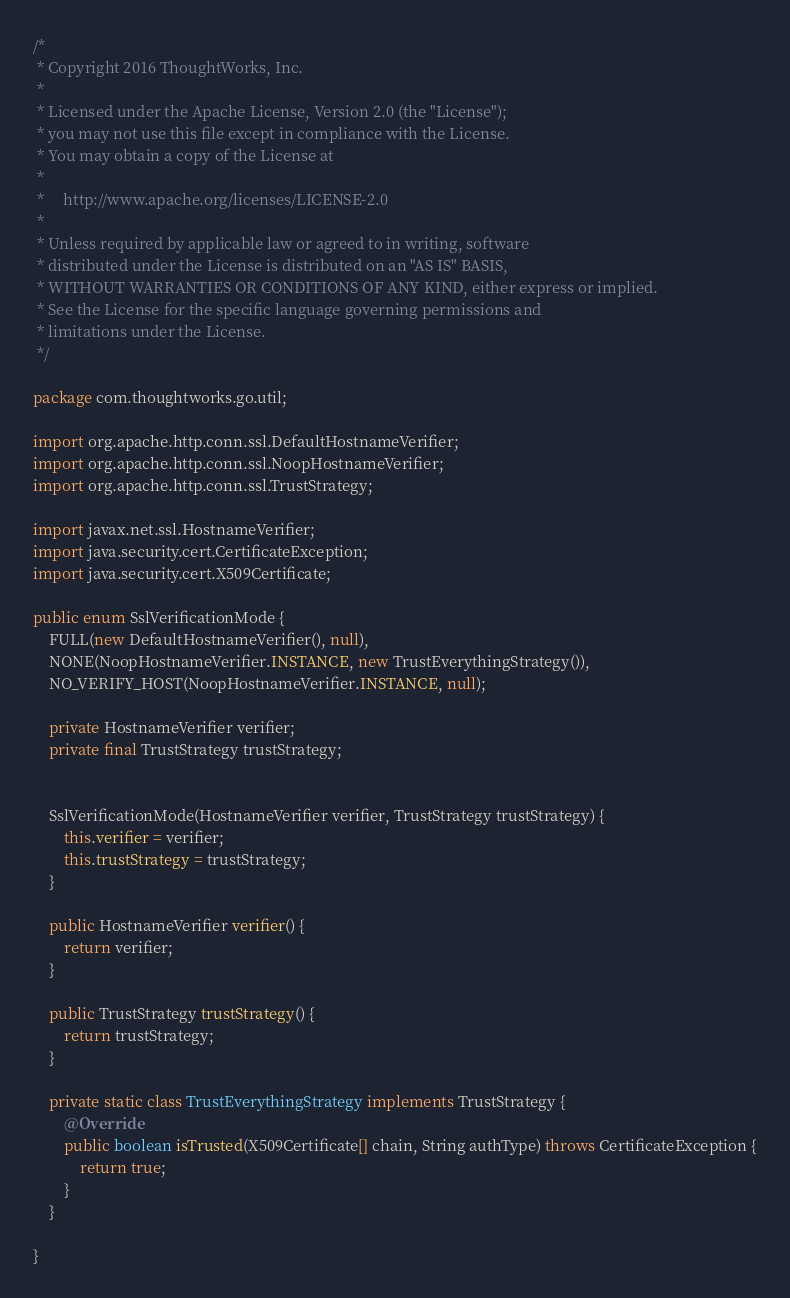Convert code to text. <code><loc_0><loc_0><loc_500><loc_500><_Java_>/*
 * Copyright 2016 ThoughtWorks, Inc.
 *
 * Licensed under the Apache License, Version 2.0 (the "License");
 * you may not use this file except in compliance with the License.
 * You may obtain a copy of the License at
 *
 *     http://www.apache.org/licenses/LICENSE-2.0
 *
 * Unless required by applicable law or agreed to in writing, software
 * distributed under the License is distributed on an "AS IS" BASIS,
 * WITHOUT WARRANTIES OR CONDITIONS OF ANY KIND, either express or implied.
 * See the License for the specific language governing permissions and
 * limitations under the License.
 */

package com.thoughtworks.go.util;

import org.apache.http.conn.ssl.DefaultHostnameVerifier;
import org.apache.http.conn.ssl.NoopHostnameVerifier;
import org.apache.http.conn.ssl.TrustStrategy;

import javax.net.ssl.HostnameVerifier;
import java.security.cert.CertificateException;
import java.security.cert.X509Certificate;

public enum SslVerificationMode {
    FULL(new DefaultHostnameVerifier(), null),
    NONE(NoopHostnameVerifier.INSTANCE, new TrustEverythingStrategy()),
    NO_VERIFY_HOST(NoopHostnameVerifier.INSTANCE, null);

    private HostnameVerifier verifier;
    private final TrustStrategy trustStrategy;


    SslVerificationMode(HostnameVerifier verifier, TrustStrategy trustStrategy) {
        this.verifier = verifier;
        this.trustStrategy = trustStrategy;
    }

    public HostnameVerifier verifier() {
        return verifier;
    }

    public TrustStrategy trustStrategy() {
        return trustStrategy;
    }

    private static class TrustEverythingStrategy implements TrustStrategy {
        @Override
        public boolean isTrusted(X509Certificate[] chain, String authType) throws CertificateException {
            return true;
        }
    }

}
</code> 